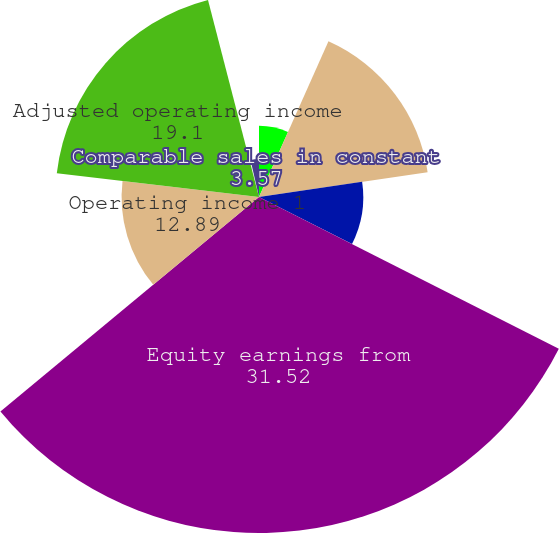Convert chart. <chart><loc_0><loc_0><loc_500><loc_500><pie_chart><fcel>Sales<fcel>Gross profit<fcel>Selling general and<fcel>Equity earnings from<fcel>Operating income 1<fcel>Adjusted operating income<fcel>Comparable sales 3<fcel>Comparable sales in constant<nl><fcel>6.68%<fcel>15.99%<fcel>9.78%<fcel>31.52%<fcel>12.89%<fcel>19.1%<fcel>0.46%<fcel>3.57%<nl></chart> 